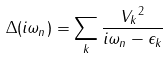<formula> <loc_0><loc_0><loc_500><loc_500>\Delta ( i \omega _ { n } ) = \sum _ { k } \frac { { V _ { k } } ^ { 2 } } { i \omega _ { n } - \epsilon _ { k } }</formula> 